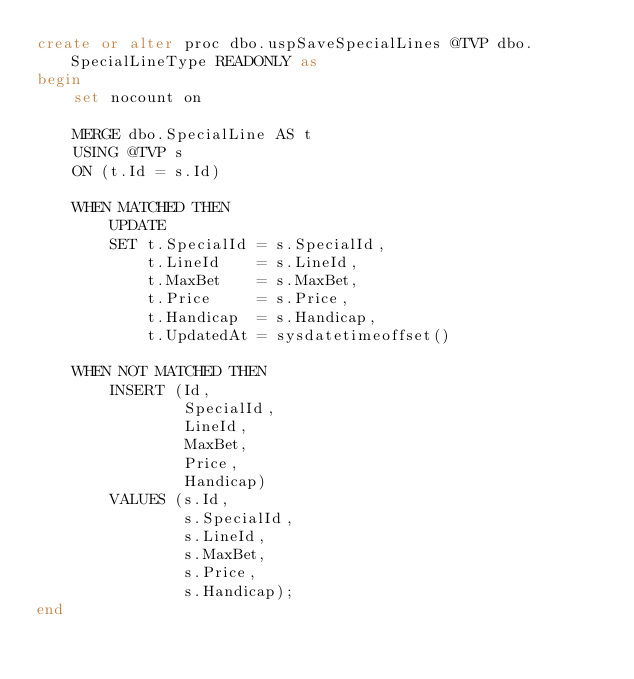<code> <loc_0><loc_0><loc_500><loc_500><_SQL_>create or alter proc dbo.uspSaveSpecialLines @TVP dbo.SpecialLineType READONLY as
begin
    set nocount on

    MERGE dbo.SpecialLine AS t
    USING @TVP s
    ON (t.Id = s.Id)

    WHEN MATCHED THEN
        UPDATE
        SET t.SpecialId = s.SpecialId,
            t.LineId    = s.LineId,
            t.MaxBet    = s.MaxBet,
            t.Price     = s.Price,
            t.Handicap  = s.Handicap,
            t.UpdatedAt = sysdatetimeoffset()

    WHEN NOT MATCHED THEN
        INSERT (Id,
                SpecialId,
                LineId,
                MaxBet,
                Price,
                Handicap)
        VALUES (s.Id,
                s.SpecialId,
                s.LineId,
                s.MaxBet,
                s.Price,
                s.Handicap);
end
</code> 